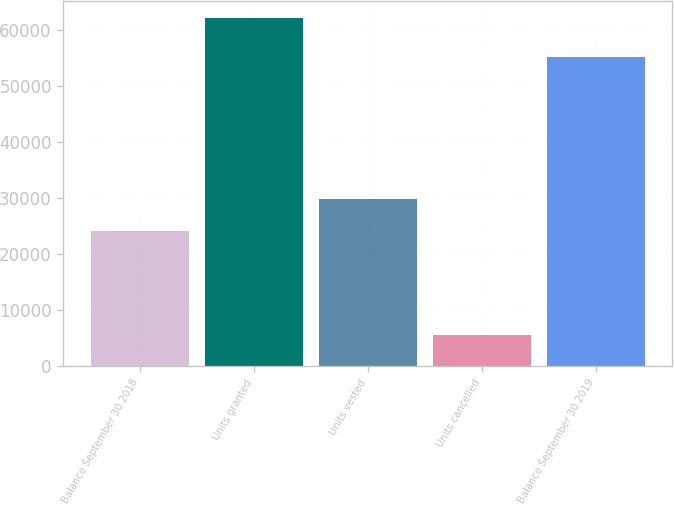Convert chart to OTSL. <chart><loc_0><loc_0><loc_500><loc_500><bar_chart><fcel>Balance September 30 2018<fcel>Units granted<fcel>Units vested<fcel>Units cancelled<fcel>Balance September 30 2019<nl><fcel>24079<fcel>62154<fcel>29751.3<fcel>5431<fcel>55184<nl></chart> 